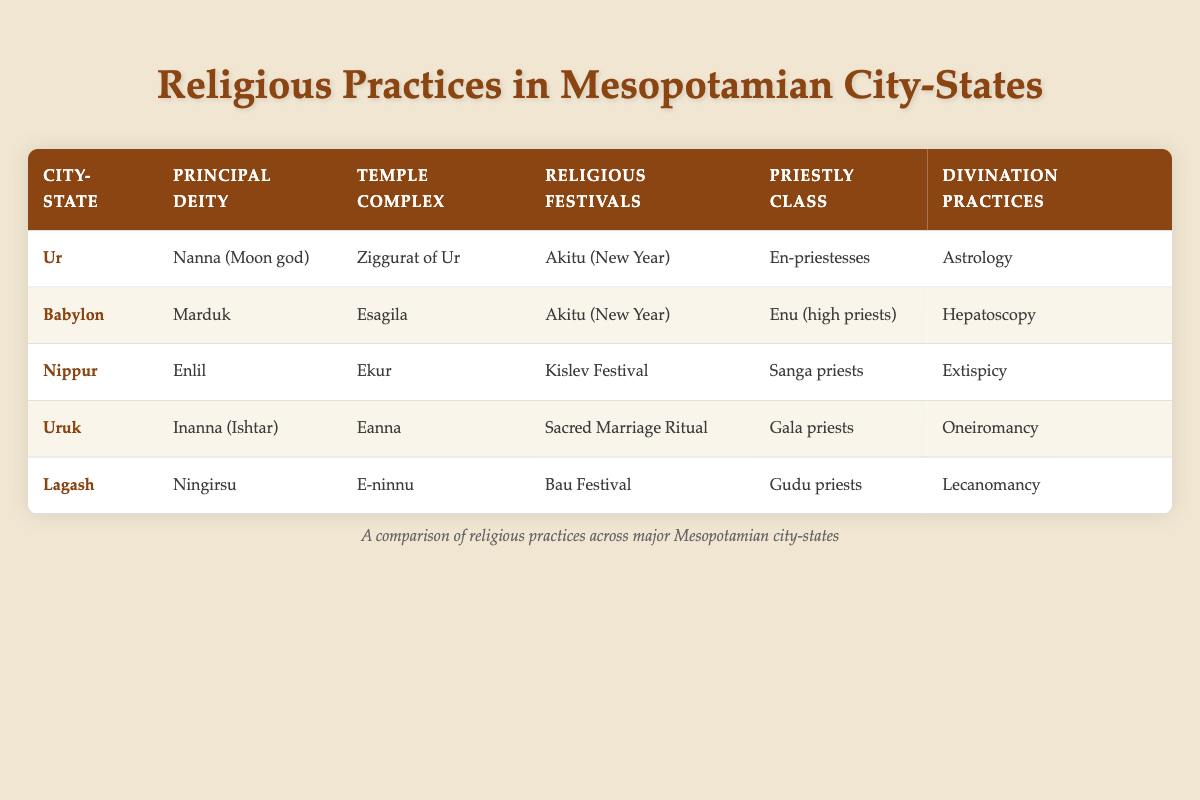What is the principal deity of Ur? The principal deity of Ur is specified in the table under the "Principal Deity" column for the city-state "Ur." It states that the principal deity is Nanna (Moon god).
Answer: Nanna (Moon god) Which city-state has the temple complex named Esagila? By referring to the table, we can look for the "Temple Complex" column. It lists Esagila under the city-state "Babylon."
Answer: Babylon Do all city-states celebrate the Akitu festival? By examining the "Religious Festivals" column, we can see that both Ur and Babylon celebrate the Akitu festival, while the others celebrate different festivals. Therefore, not all city-states celebrate it.
Answer: No How many different divination practices are listed in the table? Looking under the "Divination Practices" column, there are five distinct practices mentioned: Astrology, Hepatoscopy, Extispicy, Oneiromancy, and Lecanomancy. Thus, we count them to find there are five different practices.
Answer: 5 Which city-state has the largest representation of priestly classes based on the table? To determine this, we look at the "Priestly Class" column for each city-state. Each city-state has a distinct type of priests listed, meaning no single city-state has a larger or repeated representation.
Answer: None, all are unique What is the relationship between the principal deities and the corresponding temple complexes? We can analyze the table by comparing the "Principal Deity" and "Temple Complex" columns. Each city-state has its specific principal deity paired with its unique temple complex. This shows a direct relationship where each deity is worshipped in their dedicated temple.
Answer: Each deity has a dedicated temple complex Which city-state has the unique festival of the Sacred Marriage Ritual? By inspecting the "Religious Festivals" column, we find that the Sacred Marriage Ritual is listed solely under the city-state "Uruk," indicating that it is unique to Uruk.
Answer: Uruk Does Uruk have a priestly class similar to that of Ur? The table indicates that Uruk has Gala priests, while Ur lists En-priestesses as its class. These are different types of priests, indicating that Uruk does not share a similar priestly class with Ur.
Answer: No How does the divination practice of Nippur differ from that of Babylon? According to the "Divination Practices" column, Nippur uses Extispicy, while Babylon employs Hepatoscopy for divination. This indicates they utilize different methods for their divination practices.
Answer: They use different methods 